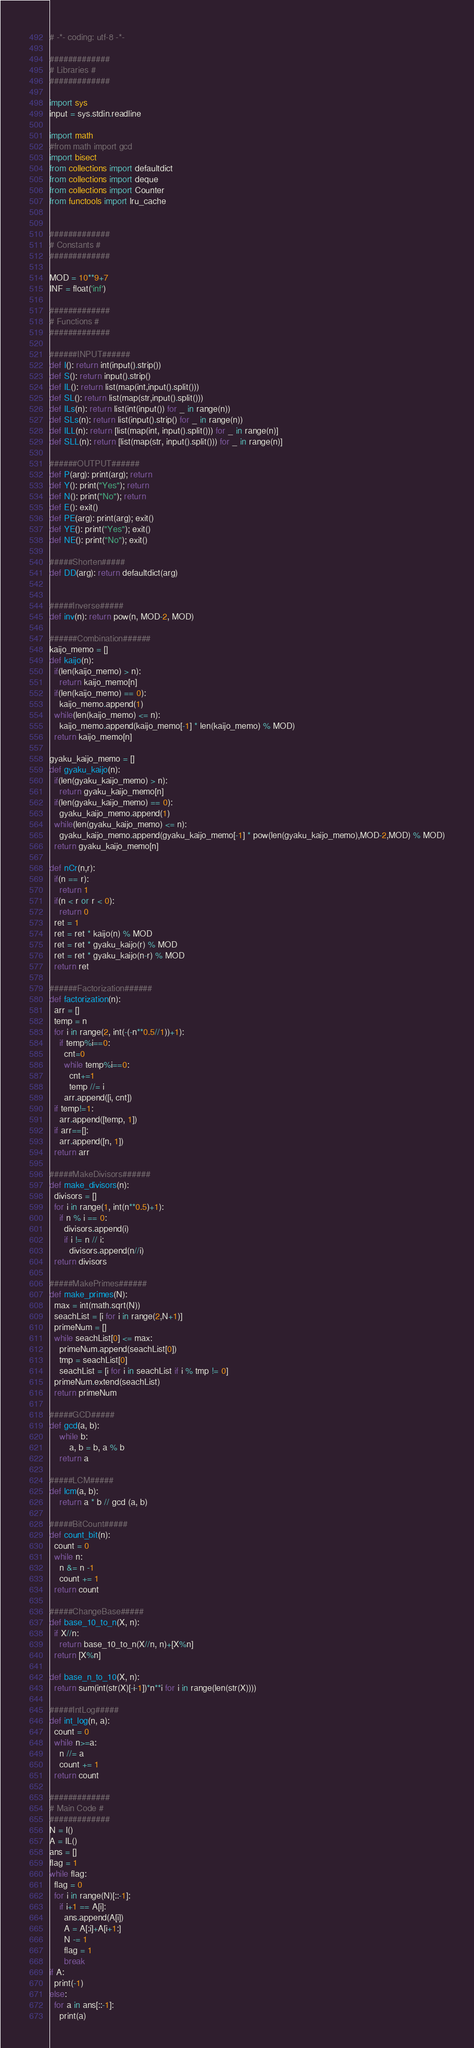<code> <loc_0><loc_0><loc_500><loc_500><_Python_># -*- coding: utf-8 -*-

#############
# Libraries #
#############

import sys
input = sys.stdin.readline

import math
#from math import gcd
import bisect
from collections import defaultdict
from collections import deque
from collections import Counter
from functools import lru_cache


#############
# Constants #
#############

MOD = 10**9+7
INF = float('inf')

#############
# Functions #
#############

######INPUT######
def I(): return int(input().strip())
def S(): return input().strip()
def IL(): return list(map(int,input().split()))
def SL(): return list(map(str,input().split()))
def ILs(n): return list(int(input()) for _ in range(n))
def SLs(n): return list(input().strip() for _ in range(n))
def ILL(n): return [list(map(int, input().split())) for _ in range(n)]
def SLL(n): return [list(map(str, input().split())) for _ in range(n)]

######OUTPUT######
def P(arg): print(arg); return
def Y(): print("Yes"); return
def N(): print("No"); return
def E(): exit()
def PE(arg): print(arg); exit()
def YE(): print("Yes"); exit()
def NE(): print("No"); exit()

#####Shorten#####
def DD(arg): return defaultdict(arg)


#####Inverse#####
def inv(n): return pow(n, MOD-2, MOD)

######Combination######
kaijo_memo = []
def kaijo(n):
  if(len(kaijo_memo) > n):
    return kaijo_memo[n]
  if(len(kaijo_memo) == 0):
    kaijo_memo.append(1)
  while(len(kaijo_memo) <= n):
    kaijo_memo.append(kaijo_memo[-1] * len(kaijo_memo) % MOD)
  return kaijo_memo[n]

gyaku_kaijo_memo = []
def gyaku_kaijo(n):
  if(len(gyaku_kaijo_memo) > n):
    return gyaku_kaijo_memo[n]
  if(len(gyaku_kaijo_memo) == 0):
    gyaku_kaijo_memo.append(1)
  while(len(gyaku_kaijo_memo) <= n):
    gyaku_kaijo_memo.append(gyaku_kaijo_memo[-1] * pow(len(gyaku_kaijo_memo),MOD-2,MOD) % MOD)
  return gyaku_kaijo_memo[n]

def nCr(n,r):
  if(n == r):
    return 1
  if(n < r or r < 0):
    return 0
  ret = 1
  ret = ret * kaijo(n) % MOD
  ret = ret * gyaku_kaijo(r) % MOD
  ret = ret * gyaku_kaijo(n-r) % MOD
  return ret

######Factorization######
def factorization(n):
  arr = []
  temp = n
  for i in range(2, int(-(-n**0.5//1))+1):
    if temp%i==0:
      cnt=0
      while temp%i==0: 
        cnt+=1 
        temp //= i
      arr.append([i, cnt])
  if temp!=1:
    arr.append([temp, 1])
  if arr==[]:
    arr.append([n, 1])
  return arr

#####MakeDivisors######
def make_divisors(n):
  divisors = []
  for i in range(1, int(n**0.5)+1):
    if n % i == 0:
      divisors.append(i)
      if i != n // i: 
        divisors.append(n//i)
  return divisors

#####MakePrimes######
def make_primes(N):
  max = int(math.sqrt(N))
  seachList = [i for i in range(2,N+1)]
  primeNum = []
  while seachList[0] <= max:
    primeNum.append(seachList[0])
    tmp = seachList[0]
    seachList = [i for i in seachList if i % tmp != 0]
  primeNum.extend(seachList)
  return primeNum

#####GCD#####
def gcd(a, b):
    while b:
        a, b = b, a % b
    return a

#####LCM#####
def lcm(a, b):
    return a * b // gcd (a, b)

#####BitCount#####
def count_bit(n):
  count = 0
  while n:
    n &= n -1
    count += 1
  return count

#####ChangeBase#####
def base_10_to_n(X, n):
  if X//n:
    return base_10_to_n(X//n, n)+[X%n]
  return [X%n]

def base_n_to_10(X, n):
  return sum(int(str(X)[-i-1])*n**i for i in range(len(str(X))))

#####IntLog#####
def int_log(n, a):
  count = 0
  while n>=a:
    n //= a
    count += 1
  return count

#############
# Main Code #
#############
N = I()
A = IL()
ans = []
flag = 1
while flag:
  flag = 0
  for i in range(N)[::-1]:
    if i+1 == A[i]:
      ans.append(A[i])
      A = A[:i]+A[i+1:]
      N -= 1
      flag = 1
      break
if A:
  print(-1)
else:
  for a in ans[::-1]:
    print(a)</code> 